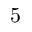Convert formula to latex. <formula><loc_0><loc_0><loc_500><loc_500>5</formula> 